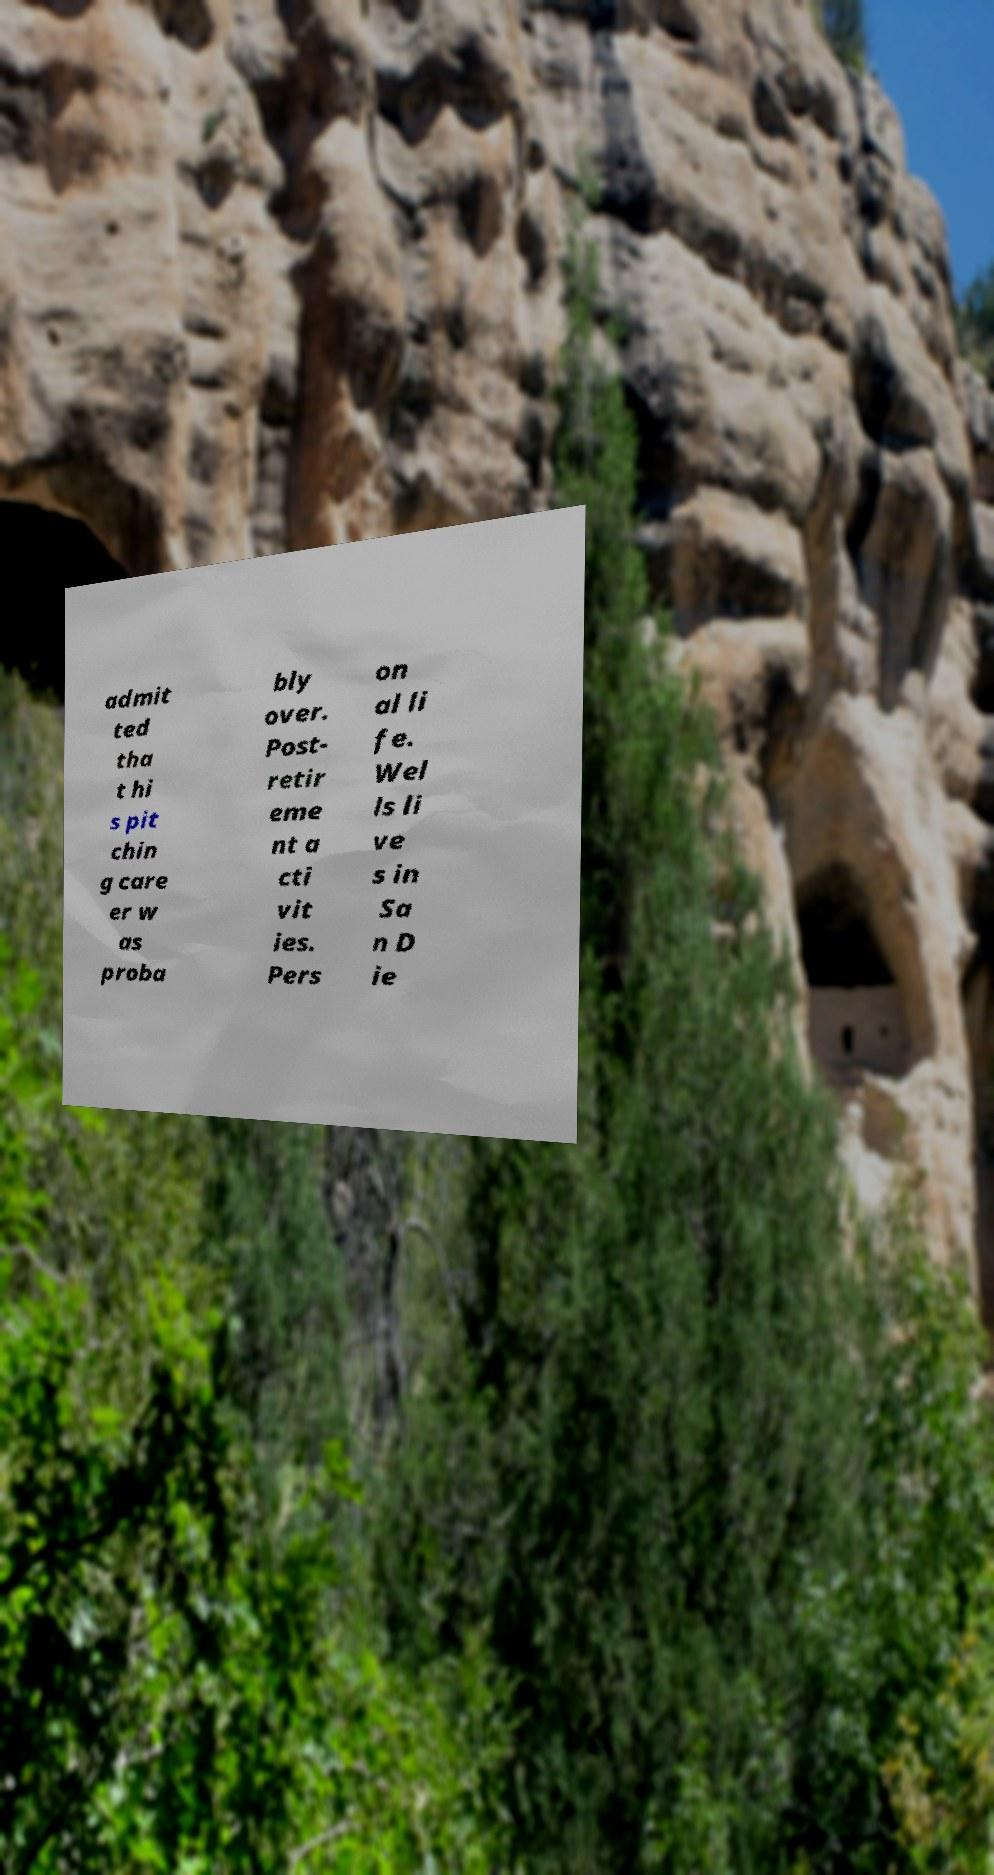I need the written content from this picture converted into text. Can you do that? admit ted tha t hi s pit chin g care er w as proba bly over. Post- retir eme nt a cti vit ies. Pers on al li fe. Wel ls li ve s in Sa n D ie 